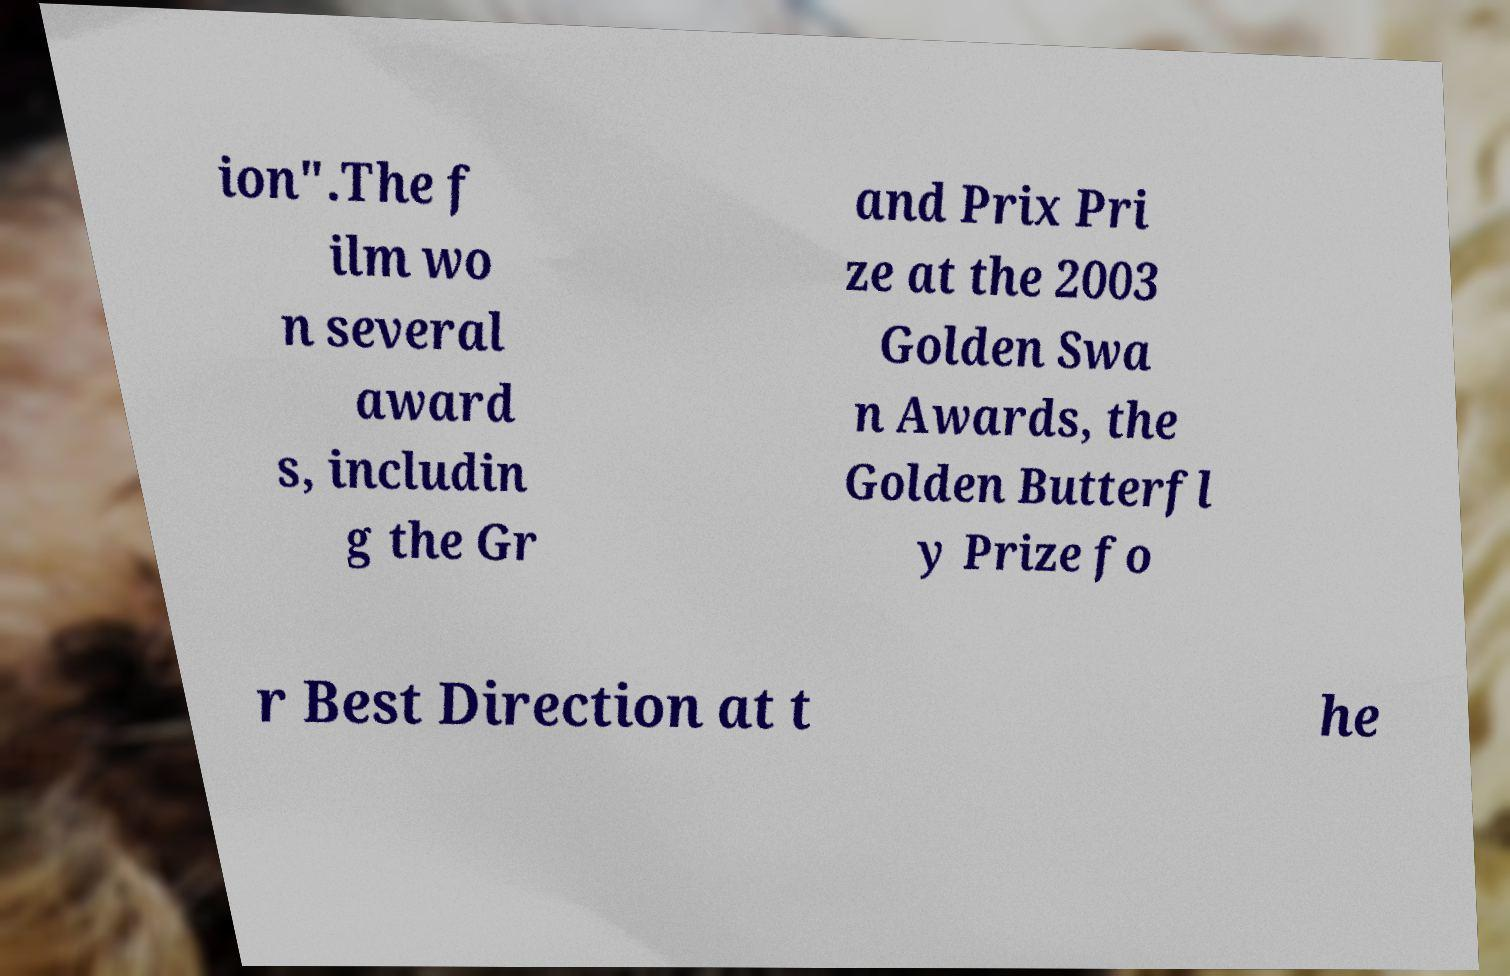Please read and relay the text visible in this image. What does it say? ion".The f ilm wo n several award s, includin g the Gr and Prix Pri ze at the 2003 Golden Swa n Awards, the Golden Butterfl y Prize fo r Best Direction at t he 